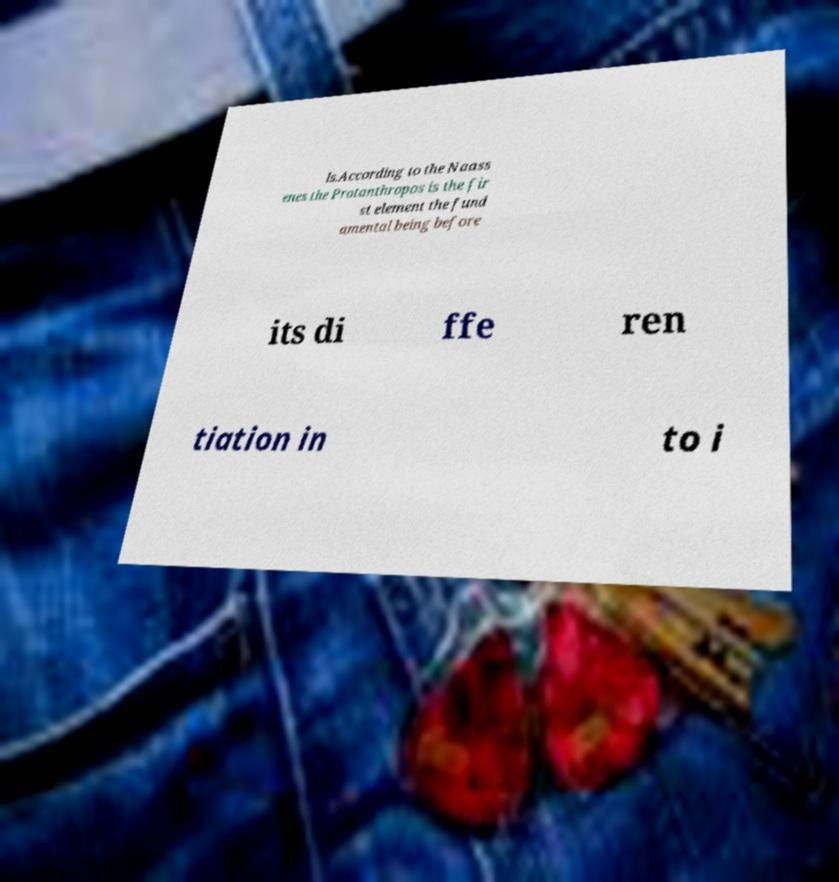What messages or text are displayed in this image? I need them in a readable, typed format. ls.According to the Naass enes the Protanthropos is the fir st element the fund amental being before its di ffe ren tiation in to i 